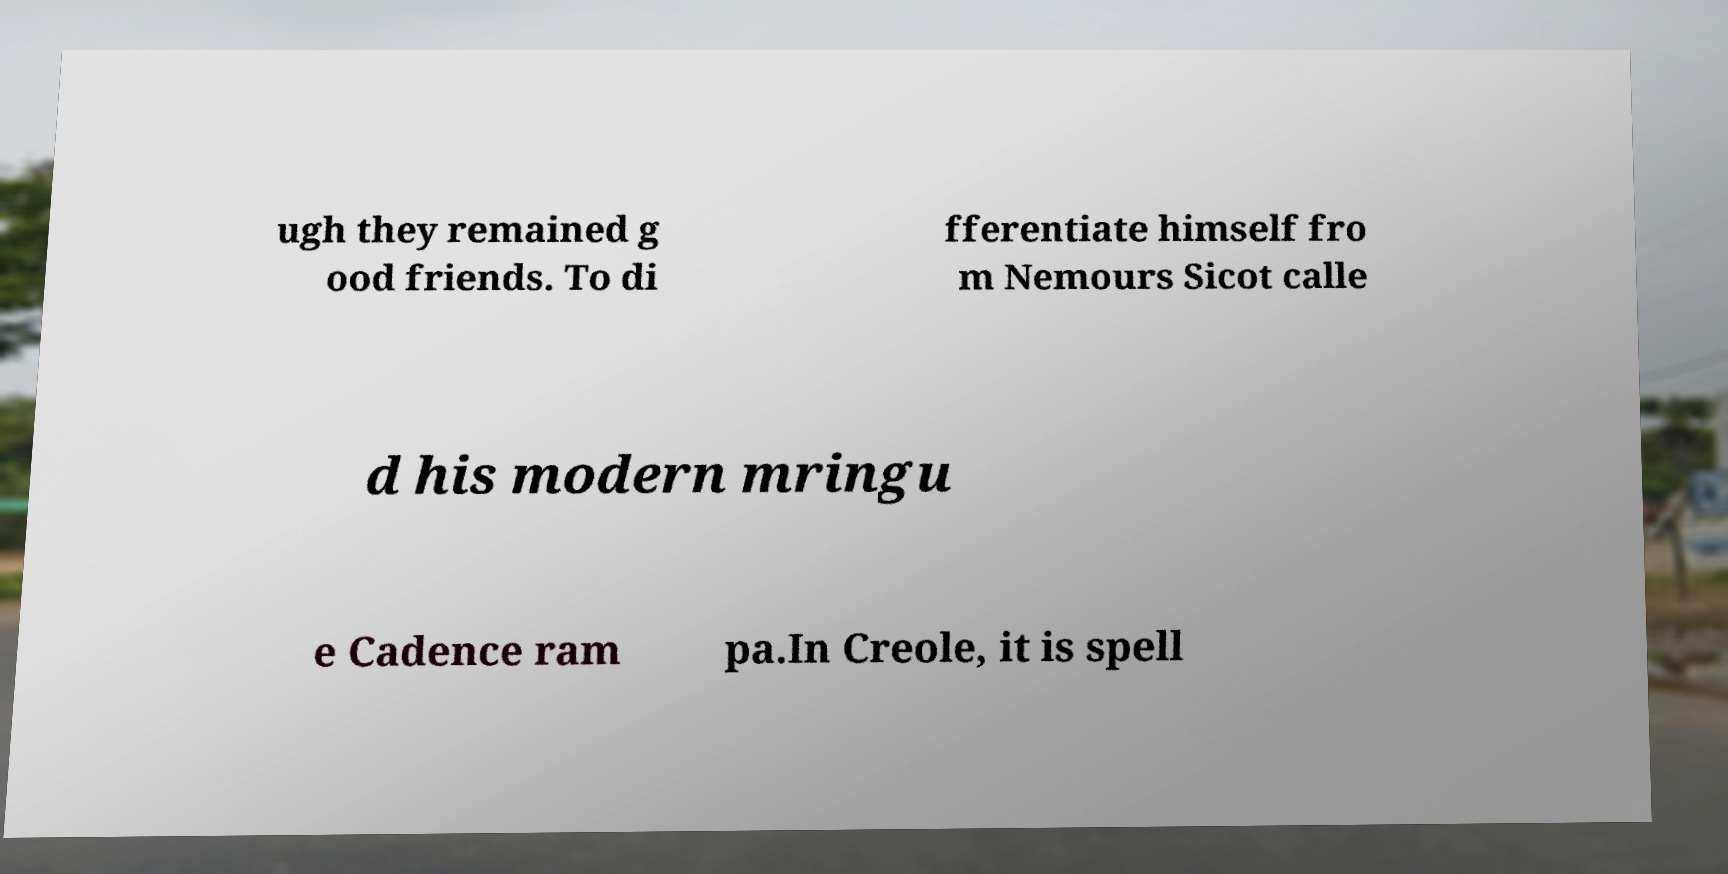Please read and relay the text visible in this image. What does it say? ugh they remained g ood friends. To di fferentiate himself fro m Nemours Sicot calle d his modern mringu e Cadence ram pa.In Creole, it is spell 